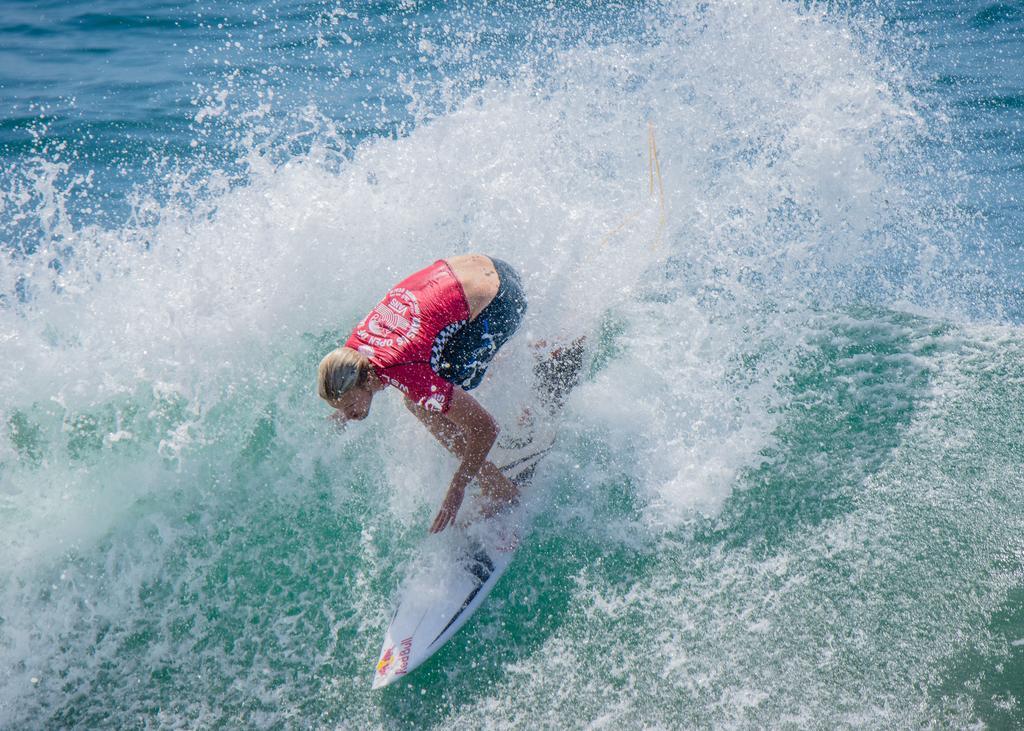Please provide a concise description of this image. In this image I can see a person wearing a t-shirt, short and surfing a board on the water. 